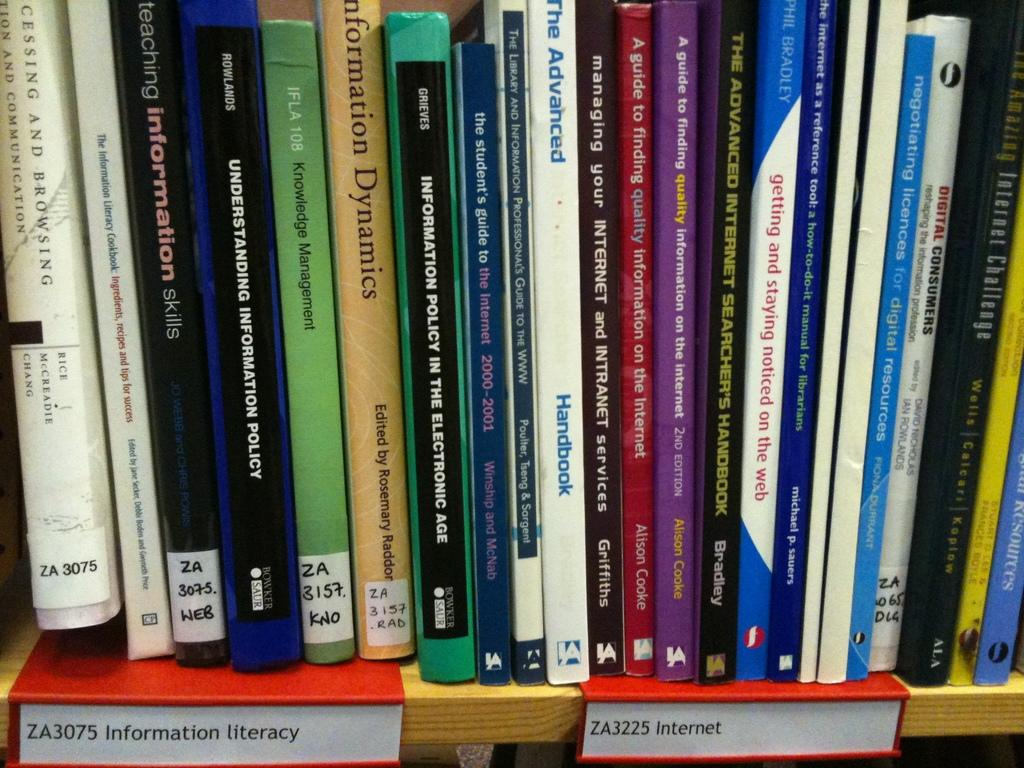Provide a one-sentence caption for the provided image. Library books lined up on a shelf with labels stating "Information literacy" and "Internet". 